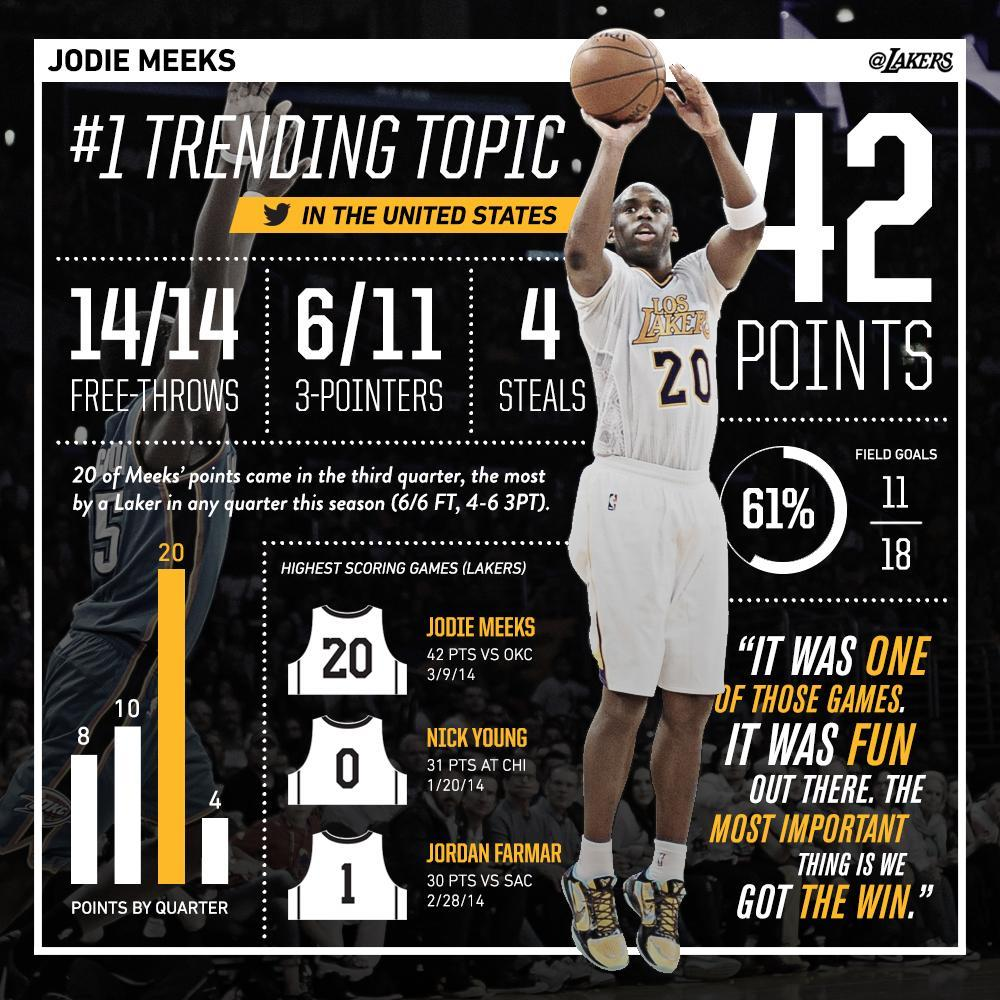Who sported the jersey number one for Los Angeles Lakers, Jodie Meeks, Nick Young, or Jordan Farmar?
Answer the question with a short phrase. Jordan Farmar What is the jersey number of Nick Young? 0 What was the points scored in the second quarter? 10 Who is the player in the image, Jodie Meeks, Nick Young, or Jordan Farmar? Jodie Meeks 